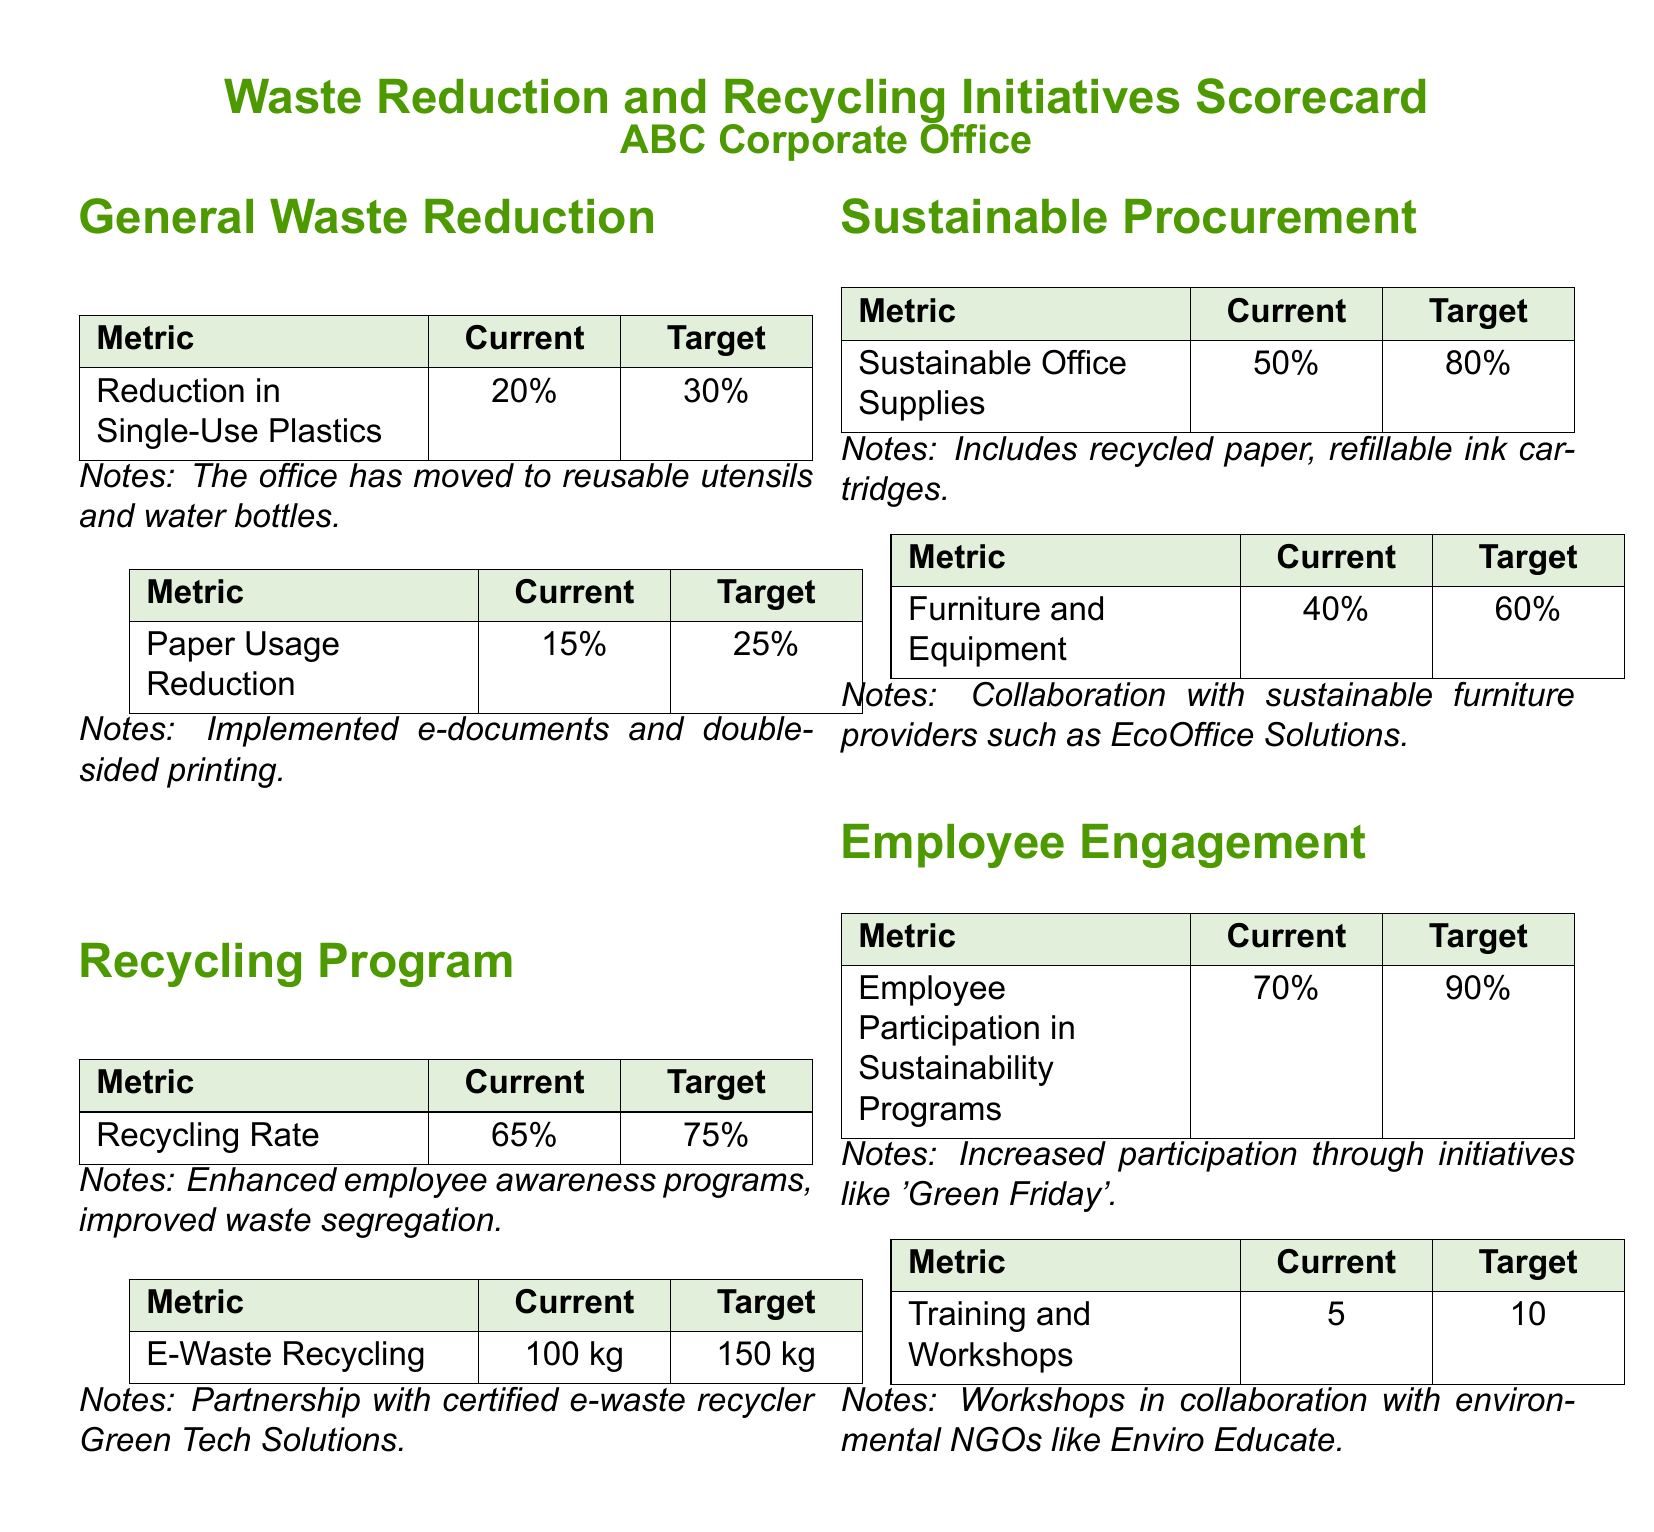What is the current reduction in single-use plastics? The document states that the current reduction in single-use plastics is 20%.
Answer: 20% What is the target paper usage reduction? The target for paper usage reduction is 25%.
Answer: 25% What is the recycling rate currently? The current recycling rate is indicated as 65%.
Answer: 65% How much e-waste is currently being recycled? The document specifies that the current e-waste recycling is 100 kg.
Answer: 100 kg What percentage of sustainable office supplies is currently used? The document notes that 50% of office supplies are currently sustainable.
Answer: 50% What is the target for employee participation in sustainability programs? The target participation in sustainability programs is 90%.
Answer: 90% What initiative was mentioned for engaging employees? The initiative mentioned is 'Green Friday'.
Answer: 'Green Friday' What is the maximum number of training and workshops planned? The document indicates a target of 10 training and workshops.
Answer: 10 Which company is partnered for e-waste recycling? The document states that the partnership is with Green Tech Solutions.
Answer: Green Tech Solutions 